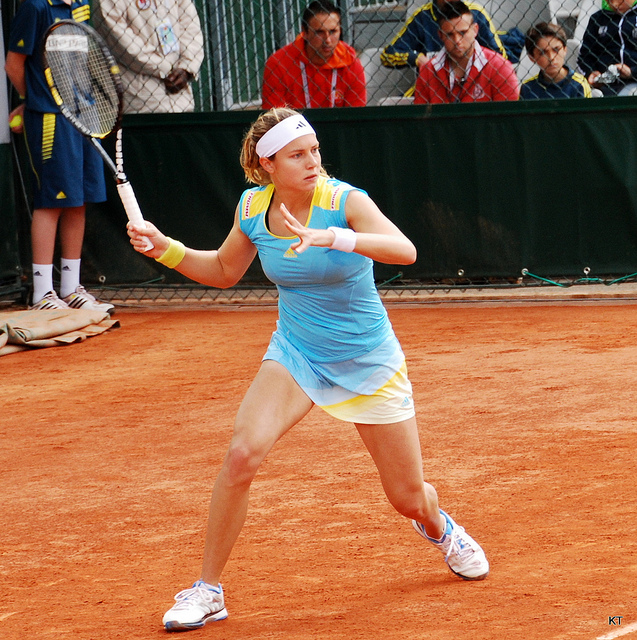Extract all visible text content from this image. M 